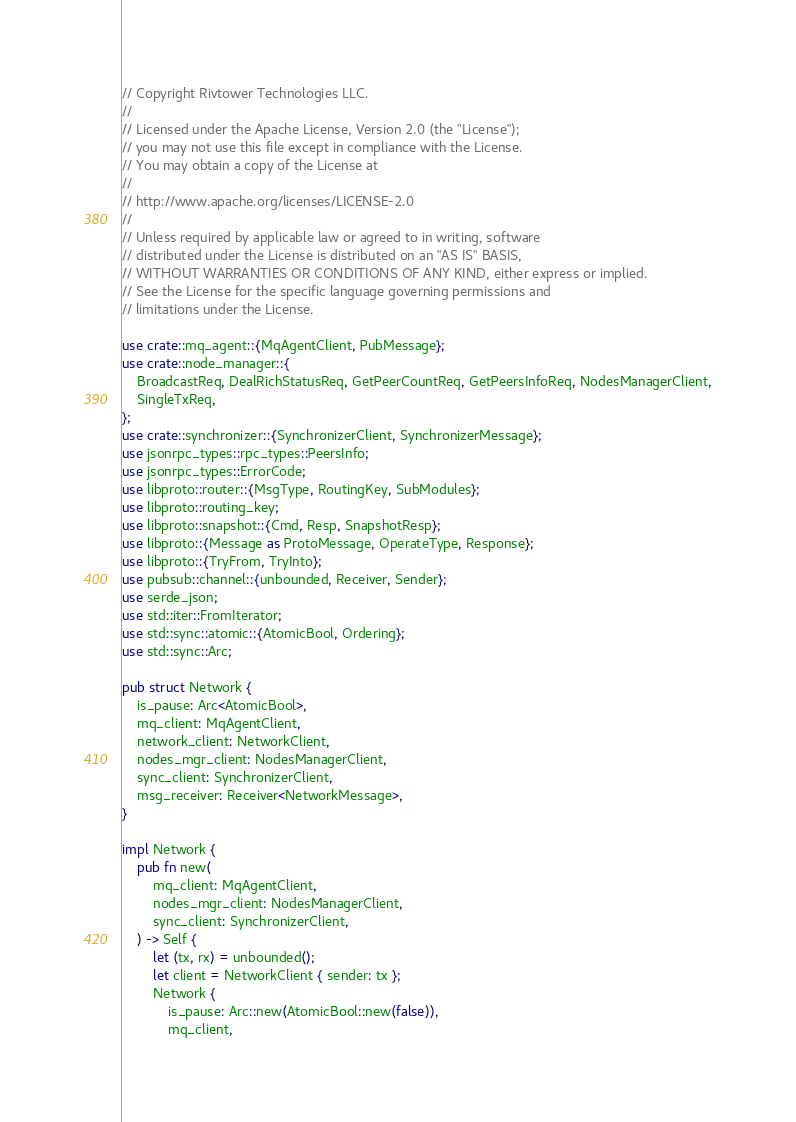<code> <loc_0><loc_0><loc_500><loc_500><_Rust_>// Copyright Rivtower Technologies LLC.
//
// Licensed under the Apache License, Version 2.0 (the "License");
// you may not use this file except in compliance with the License.
// You may obtain a copy of the License at
//
// http://www.apache.org/licenses/LICENSE-2.0
//
// Unless required by applicable law or agreed to in writing, software
// distributed under the License is distributed on an "AS IS" BASIS,
// WITHOUT WARRANTIES OR CONDITIONS OF ANY KIND, either express or implied.
// See the License for the specific language governing permissions and
// limitations under the License.

use crate::mq_agent::{MqAgentClient, PubMessage};
use crate::node_manager::{
    BroadcastReq, DealRichStatusReq, GetPeerCountReq, GetPeersInfoReq, NodesManagerClient,
    SingleTxReq,
};
use crate::synchronizer::{SynchronizerClient, SynchronizerMessage};
use jsonrpc_types::rpc_types::PeersInfo;
use jsonrpc_types::ErrorCode;
use libproto::router::{MsgType, RoutingKey, SubModules};
use libproto::routing_key;
use libproto::snapshot::{Cmd, Resp, SnapshotResp};
use libproto::{Message as ProtoMessage, OperateType, Response};
use libproto::{TryFrom, TryInto};
use pubsub::channel::{unbounded, Receiver, Sender};
use serde_json;
use std::iter::FromIterator;
use std::sync::atomic::{AtomicBool, Ordering};
use std::sync::Arc;

pub struct Network {
    is_pause: Arc<AtomicBool>,
    mq_client: MqAgentClient,
    network_client: NetworkClient,
    nodes_mgr_client: NodesManagerClient,
    sync_client: SynchronizerClient,
    msg_receiver: Receiver<NetworkMessage>,
}

impl Network {
    pub fn new(
        mq_client: MqAgentClient,
        nodes_mgr_client: NodesManagerClient,
        sync_client: SynchronizerClient,
    ) -> Self {
        let (tx, rx) = unbounded();
        let client = NetworkClient { sender: tx };
        Network {
            is_pause: Arc::new(AtomicBool::new(false)),
            mq_client,</code> 